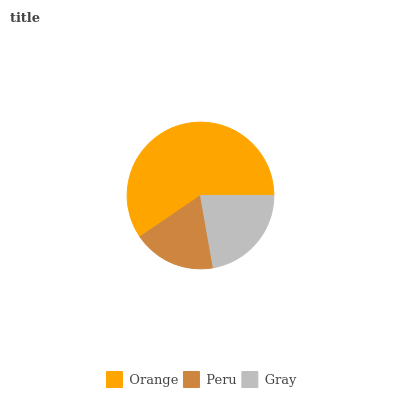Is Peru the minimum?
Answer yes or no. Yes. Is Orange the maximum?
Answer yes or no. Yes. Is Gray the minimum?
Answer yes or no. No. Is Gray the maximum?
Answer yes or no. No. Is Gray greater than Peru?
Answer yes or no. Yes. Is Peru less than Gray?
Answer yes or no. Yes. Is Peru greater than Gray?
Answer yes or no. No. Is Gray less than Peru?
Answer yes or no. No. Is Gray the high median?
Answer yes or no. Yes. Is Gray the low median?
Answer yes or no. Yes. Is Peru the high median?
Answer yes or no. No. Is Peru the low median?
Answer yes or no. No. 